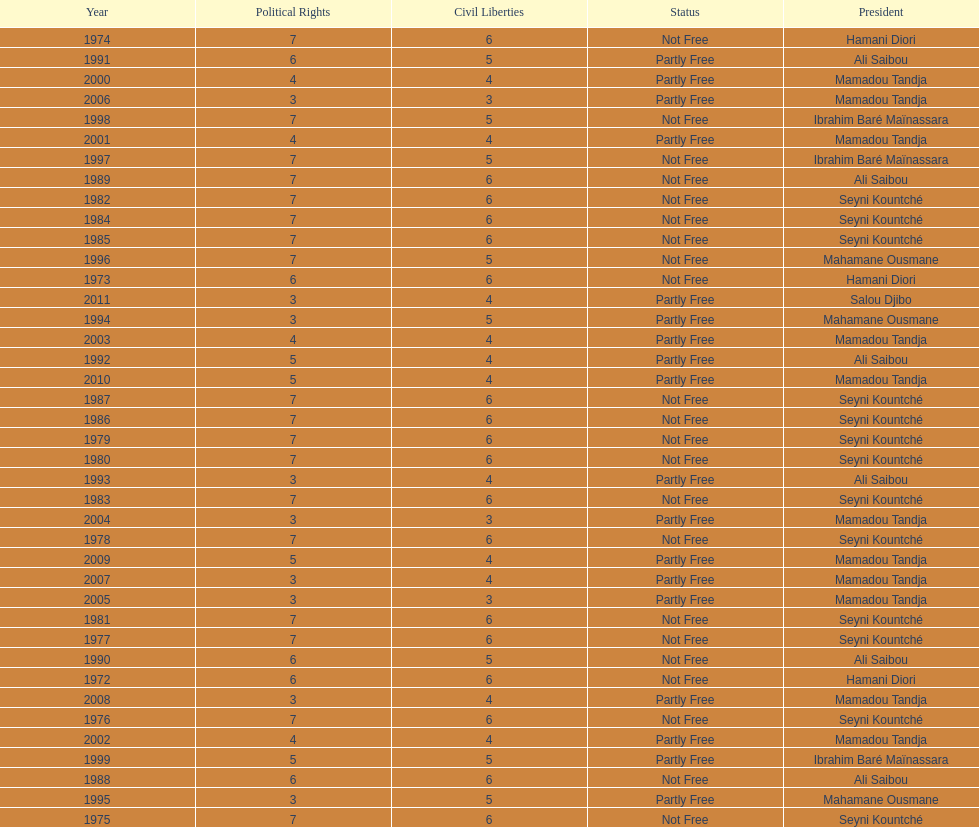How many years was ali saibou president? 6. 